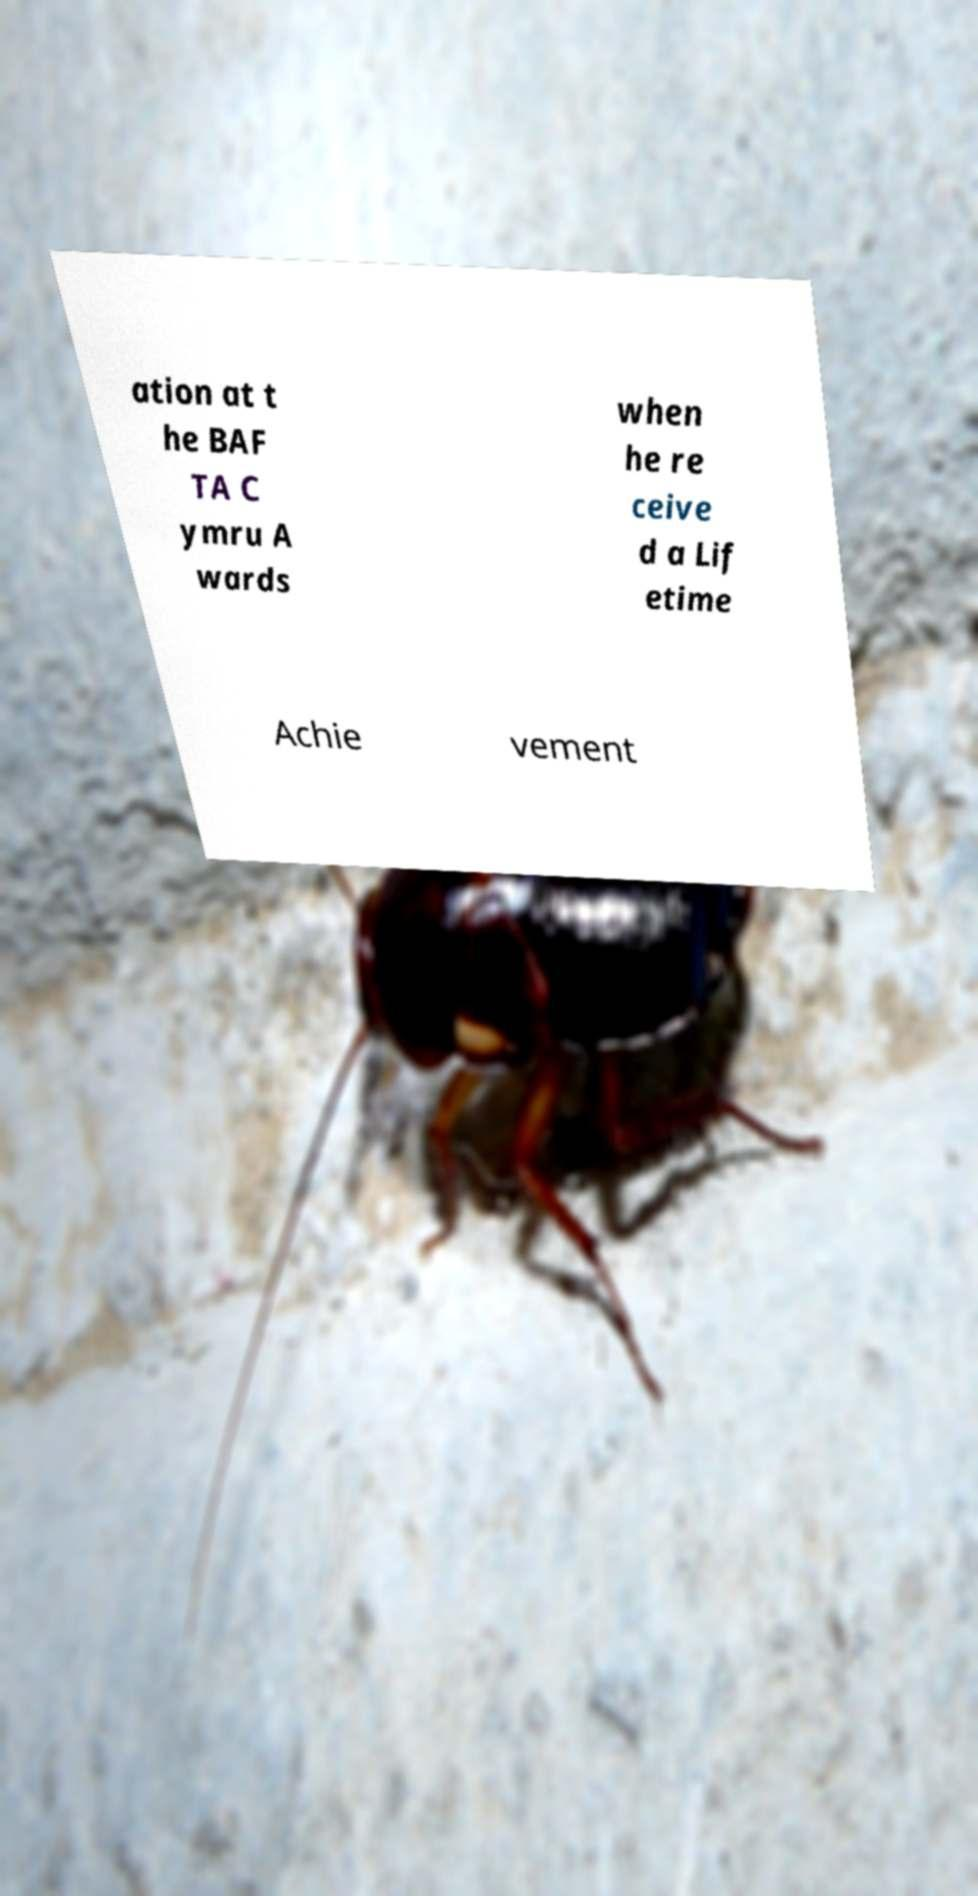Could you extract and type out the text from this image? ation at t he BAF TA C ymru A wards when he re ceive d a Lif etime Achie vement 